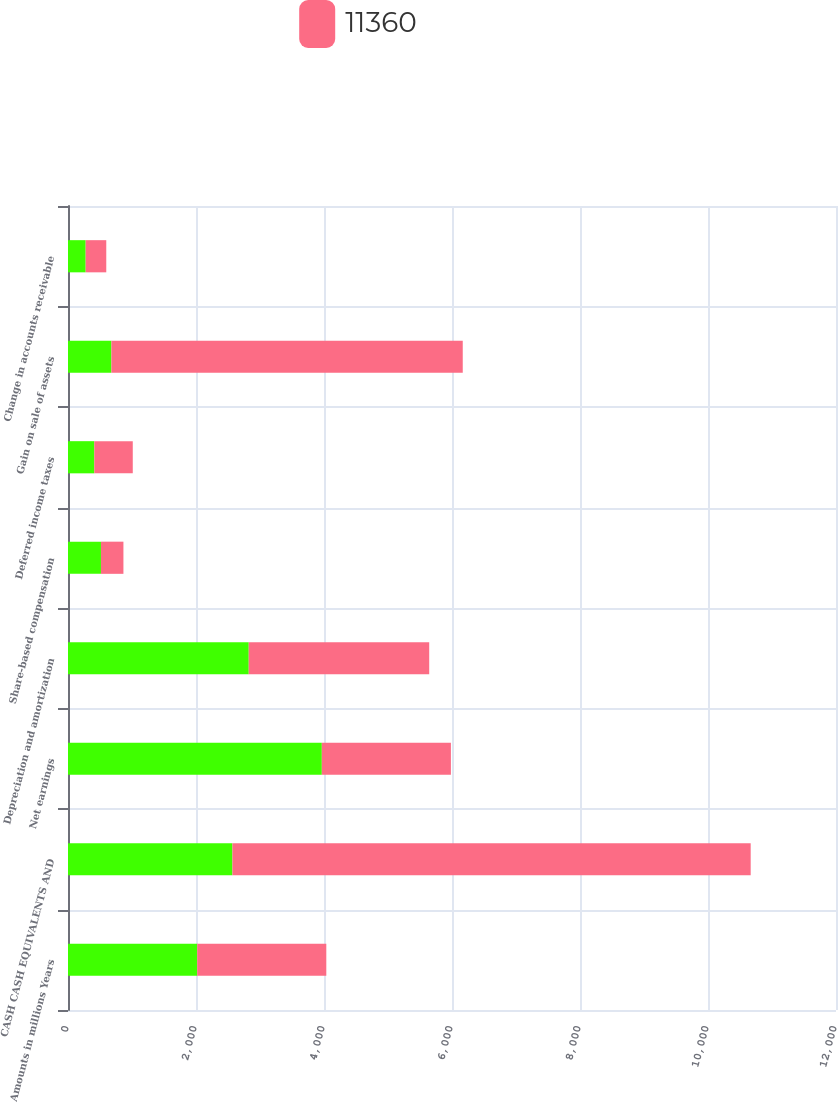Convert chart. <chart><loc_0><loc_0><loc_500><loc_500><stacked_bar_chart><ecel><fcel>Amounts in millions Years<fcel>CASH CASH EQUIVALENTS AND<fcel>Net earnings<fcel>Depreciation and amortization<fcel>Share-based compensation<fcel>Deferred income taxes<fcel>Gain on sale of assets<fcel>Change in accounts receivable<nl><fcel>nan<fcel>2019<fcel>2569<fcel>3966<fcel>2824<fcel>515<fcel>411<fcel>678<fcel>276<nl><fcel>11360<fcel>2017<fcel>8098<fcel>2017<fcel>2820<fcel>351<fcel>601<fcel>5490<fcel>322<nl></chart> 